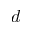Convert formula to latex. <formula><loc_0><loc_0><loc_500><loc_500>d</formula> 